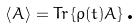Convert formula to latex. <formula><loc_0><loc_0><loc_500><loc_500>\left \langle A \right \rangle = T r \left \{ \rho ( t ) A \right \} \text {.}</formula> 